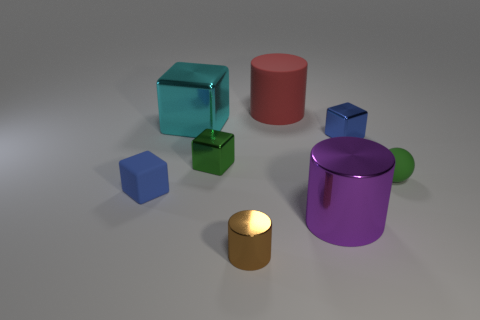What number of other things are the same material as the green sphere?
Give a very brief answer. 2. What shape is the small metal thing that is the same color as the small ball?
Offer a terse response. Cube. There is a blue cube to the left of the tiny brown shiny cylinder; what size is it?
Your answer should be very brief. Small. The purple thing that is the same material as the small brown object is what shape?
Your answer should be compact. Cylinder. Are the green block and the tiny block that is right of the small brown cylinder made of the same material?
Your answer should be very brief. Yes. Does the tiny blue object in front of the small sphere have the same shape as the blue shiny thing?
Give a very brief answer. Yes. There is a big purple object that is the same shape as the red rubber thing; what is it made of?
Offer a very short reply. Metal. There is a purple thing; does it have the same shape as the large thing on the left side of the tiny green metal thing?
Offer a very short reply. No. What is the color of the tiny object that is both in front of the ball and to the left of the brown cylinder?
Provide a succinct answer. Blue. Are any green shiny things visible?
Your answer should be compact. Yes. 